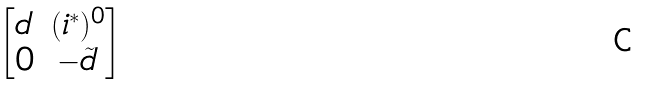<formula> <loc_0><loc_0><loc_500><loc_500>\begin{bmatrix} d & ( i ^ { * } ) ^ { 0 } \\ 0 & - \tilde { d } \end{bmatrix}</formula> 